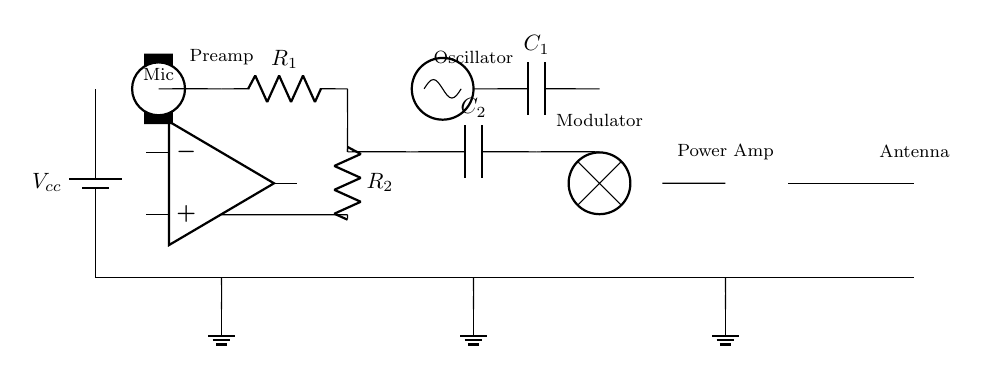What type of microphone is depicted in the circuit? The circuit diagram includes a component labeled as 'Mic,' which indicates that it is a conventional microphone.
Answer: Microphone What is the role of the component labeled 'R1'? The circuit shows 'R1' connected with the microphone and the op-amp, suggesting it is likely a resistor used for gain control or filtering the audio signal.
Answer: Gain control How many capacitors are present in the circuit? The circuit diagram shows two capacitors labeled as 'C1' and 'C2,' confirming their presence in the schematic.
Answer: Two What is the function of the oscillator in the circuit? The oscillator is marked in the diagram, which typically generates a frequency signal used for modulating the audio captured by the microphone, making it suitable for wireless transmission.
Answer: Frequency generation How does the circuit transmit audio? The audio signal is captured by the microphone, amplified by the power amplifier, and then transmitted via the antenna, which connects to the circuit at the end.
Answer: Through the antenna What is the purpose of the antenna in this circuit? The antenna is labeled in the diagram and is responsible for radiating the modulated signals into the air for wireless communication, allowing the audio to be captured remotely.
Answer: Wireless transmission What is the significance of the ground connections in the circuit? Ground connections are critical for defining a common reference point for all components in the circuit, ensuring proper functionality and stability of the electrical signals.
Answer: Common reference point 